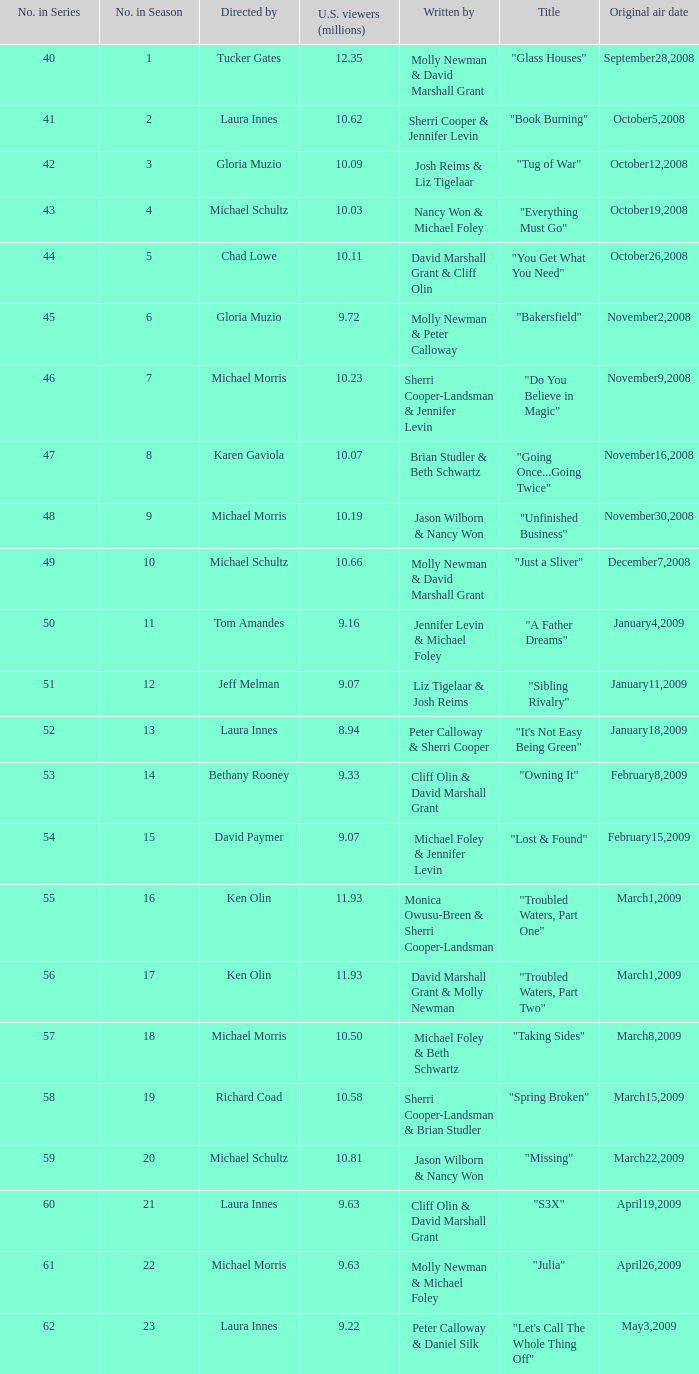What's the name of the episode seen by 9.63 millions of people in the US, whose director is Laura Innes? "S3X". 